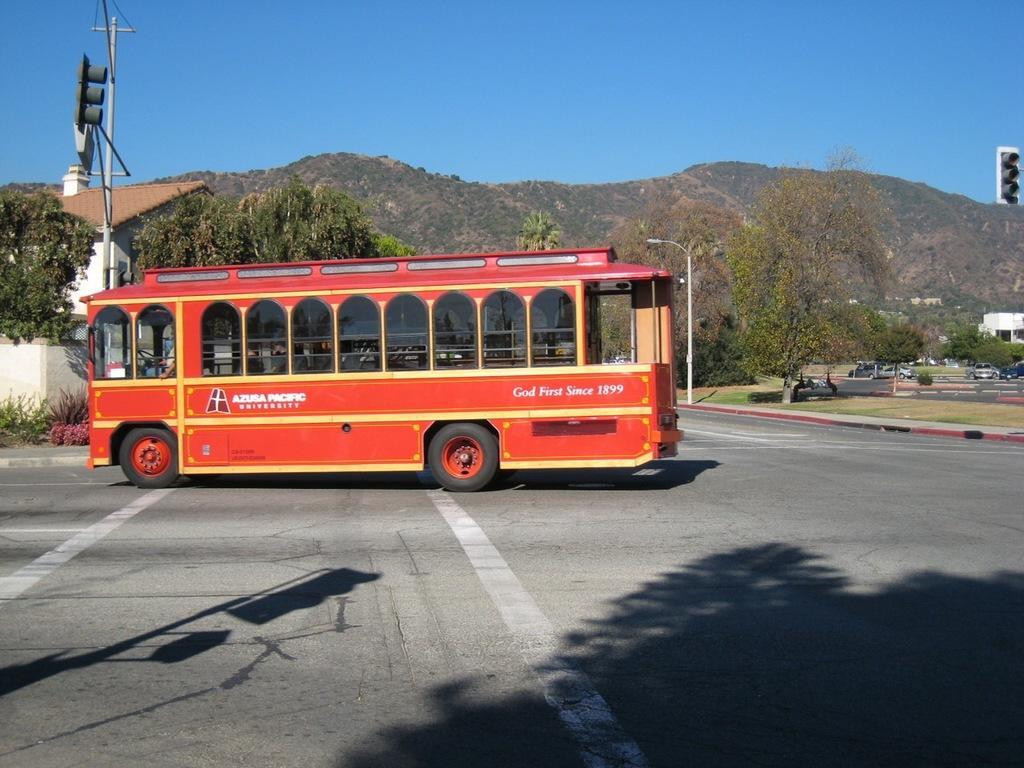What type of vehicle is in the image? There is a red bus in the image. Where is the bus located? The bus is on the road. What can be seen in the background of the image? There are trees and mountains in the background of the image. Can you see a crown on top of the bus in the image? No, there is no crown present on top of the bus in the image. 